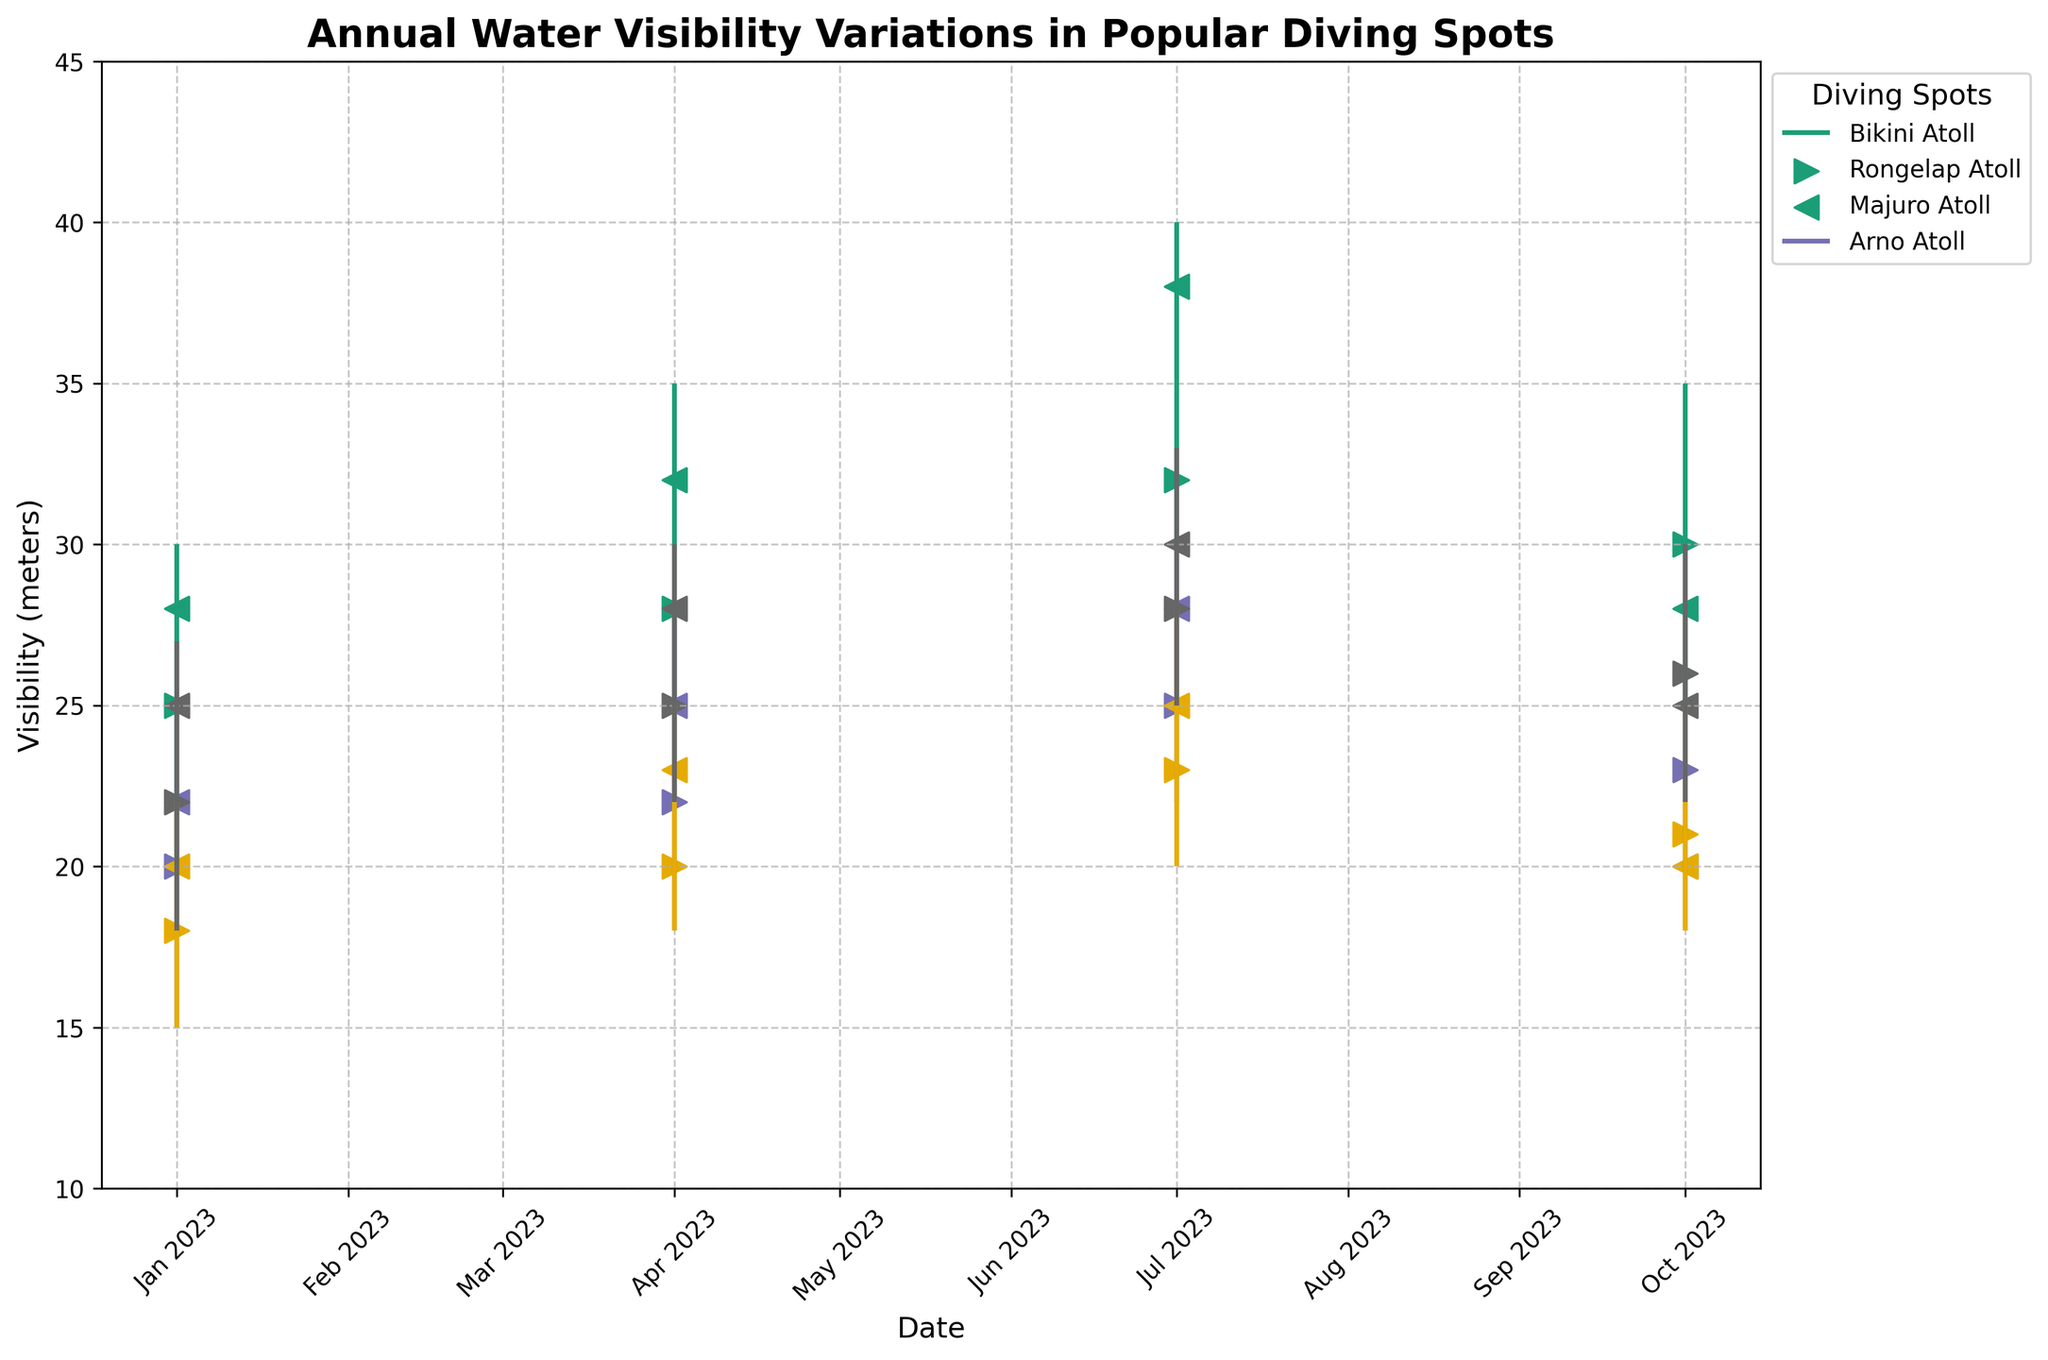What's the title of the figure? The title is prominently displayed at the top of the figure.
Answer: Annual Water Visibility Variations in Popular Diving Spots How many spots are compared in the figure? The legend on the right side of the figure lists the number of diving spots compared.
Answer: Four Which diving spot has the highest visibility in July? Look for the highest 'High' value in July across different spots and note the corresponding diving spot. For July, the highest value is 40 and belongs to Bikini Atoll.
Answer: Bikini Atoll What is the general trend of visibility for Bikini Atoll throughout the year? Analyze the trend of the visibility values (Open, High, Low, Close) across all the dates for Bikini Atoll. The values generally increase from January to July and then decrease in October.
Answer: Increasing and then decreasing Compare the visibility ranges in October for Bikini Atoll and Rongelap Atoll. Which atoll has a wider visibility range? Evaluate the difference between the 'High' and 'Low' values for both spots in October. Bikini Atoll has a visibility range of 35-25=10, and Rongelap Atoll has a range of 28-18=10. Both spots have the same range.
Answer: Both have the same range What is the total number of points (markers) on the chart for all spots combined? Each spot has four points (dates) marked on the chart (Open and Close markers for each date). With four spots, it totals to 4 * 4 = 16 points.
Answer: 16 Which season shows the highest increase in visibility for Majuro Atoll? Compare the difference in the Close and Open values across all the seasons for Majuro Atoll. The largest increase observed is from January (Open 18, Close 20) to April (Open 20, Close 23), showing a 3-meter increase.
Answer: Spring For Arno Atoll, what is the difference in visibility between January and October? Calculate the difference in the Close values for January (25) and October (25) for Arno Atoll. The difference is 25 - 25 = 0.
Answer: 0 When is the visibility at Rongelap Atoll the lowest? Look for the lowest 'Low' value for Rongelap Atoll across all dates. The lowest value is 15, which occurs in January.
Answer: January Which diving spot shows the smallest variation in visibility in any given quarter? Evaluate the visibility range (High - Low) for all spots each quarter. The smallest variation observed is for Majuro Atoll in January, with a range of 22-18 = 4.
Answer: Majuro Atoll in January 